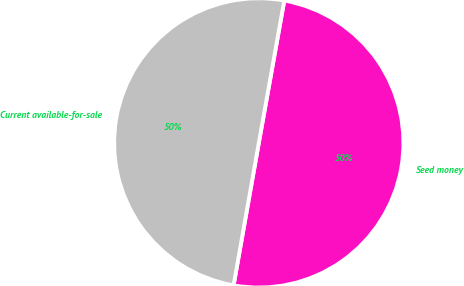Convert chart to OTSL. <chart><loc_0><loc_0><loc_500><loc_500><pie_chart><fcel>Seed money<fcel>Current available-for-sale<nl><fcel>49.97%<fcel>50.03%<nl></chart> 